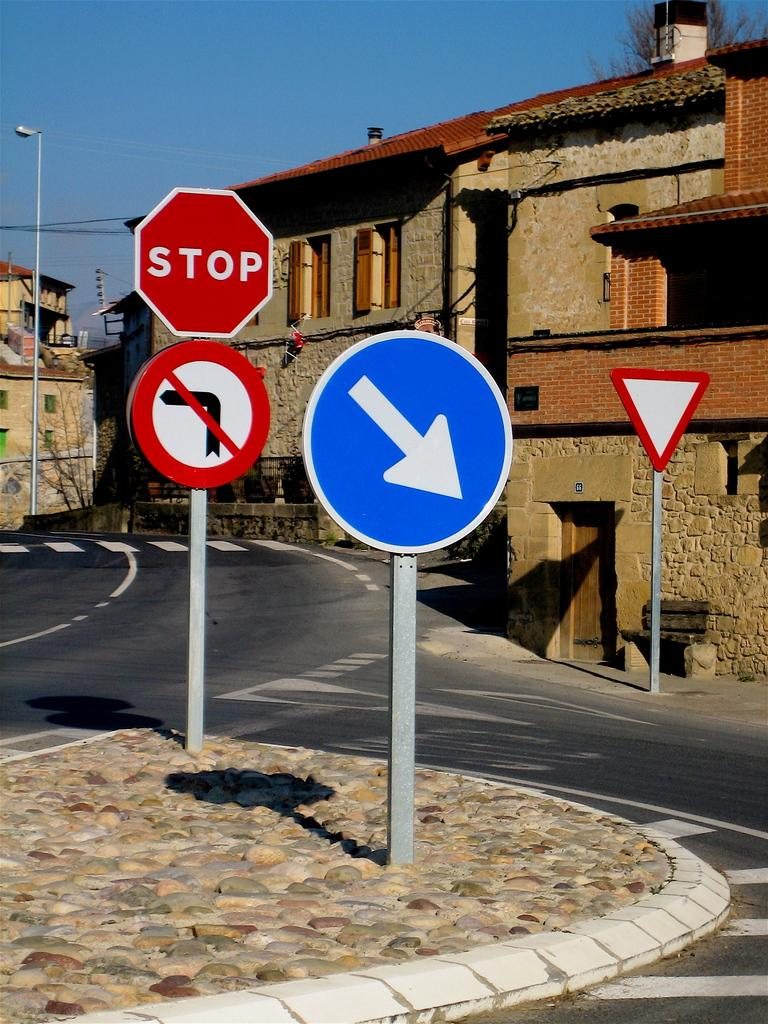<image>
Create a compact narrative representing the image presented. Different signs that includes a stop sign, yield sign, and down arrow 